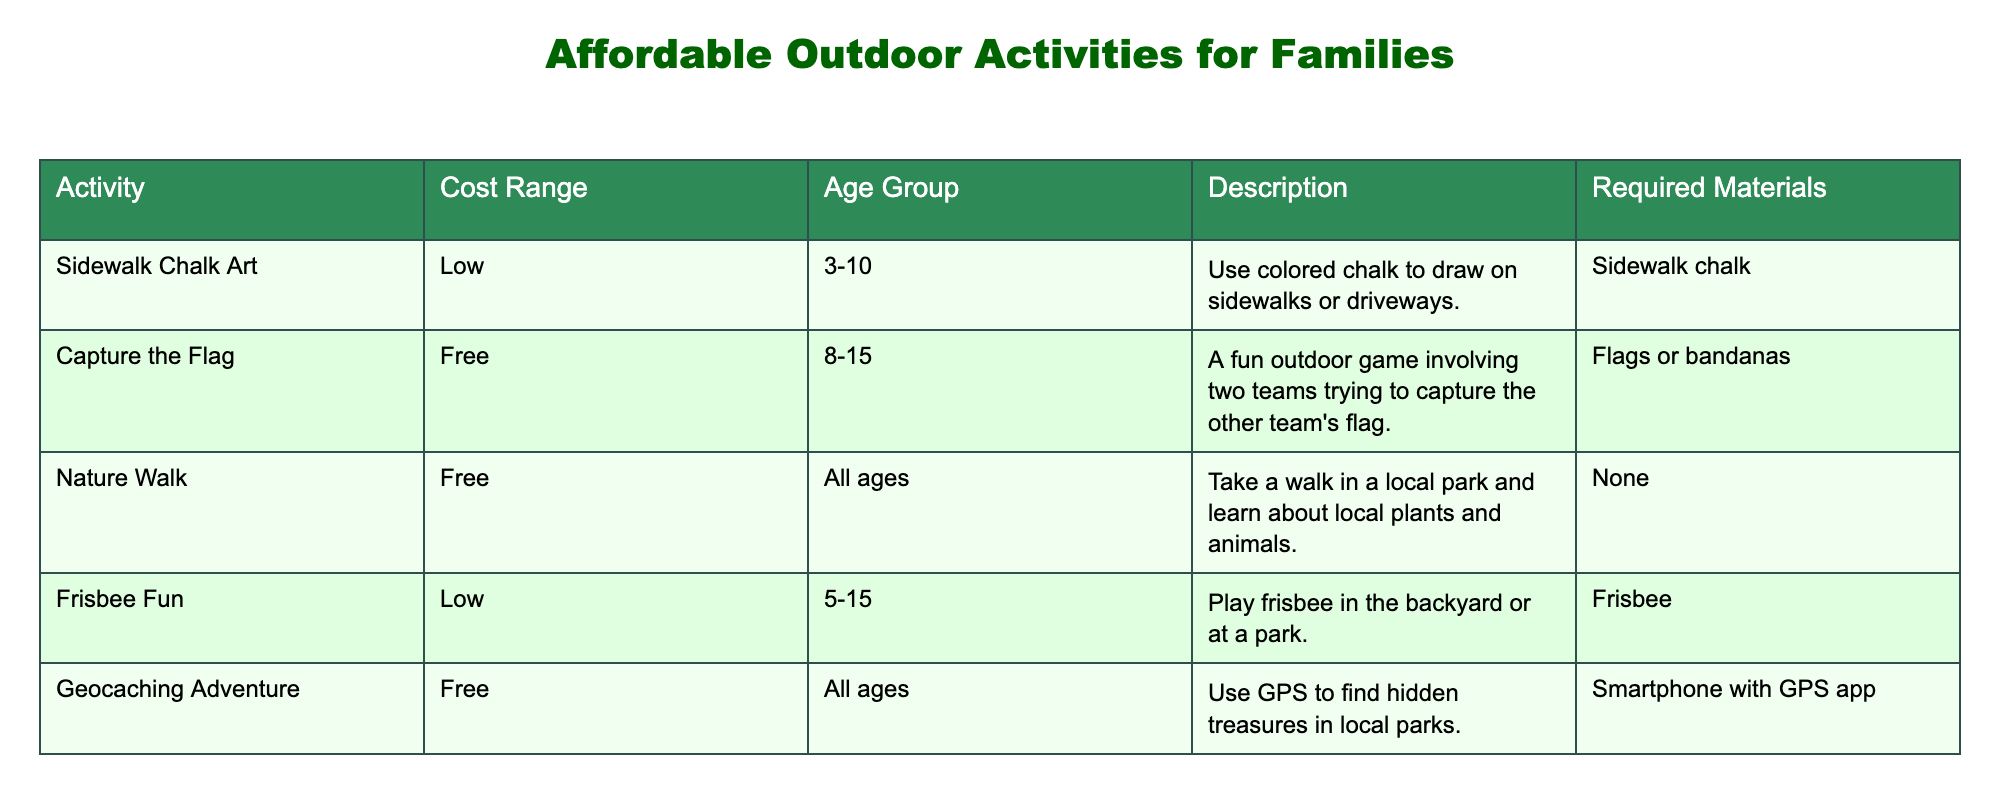What is the cost range for "Sidewalk Chalk Art"? The cost range is specified in the table under the "Cost Range" column for the activity "Sidewalk Chalk Art." It shows "Low."
Answer: Low Which activities are suitable for all ages? The table has a column for age group, and I can look for entries that say "All ages." The activities listed are "Nature Walk" and "Geocaching Adventure."
Answer: Nature Walk, Geocaching Adventure Is "Capture the Flag" the only game listed that is free? To answer this, I check the "Cost Range" column for "Capture the Flag" and see that it lists "Free." Then I look at the other activities and see that "Nature Walk" and "Geocaching Adventure" are also marked as "Free." So, the statement is false.
Answer: No What is the total number of activities with a low-cost range? I count all activities in the table that have "Low" in the "Cost Range" column. The activities are "Sidewalk Chalk Art," "Frisbee Fun." There are 2 low-cost activities.
Answer: 2 Find the most expensive activity listed. The table does not explicitly provide high-cost activities. However, I can look at the descriptions of the activities with varying cost ranges. As all listed are free or low, it appears none are expensive. However, since they are all categorized as "Low" or "Free," I conclude there isn't an expensive activity.
Answer: None How many activities can be played by children aged 10 and below? To find this, I look at the age group of each activity in the table. "Sidewalk Chalk Art" (3-10), "Frisbee Fun" (5-15), and "Nature Walk" (All ages) allow participation from children aged ten and below. So there are three suitable activities for this age group.
Answer: 3 Which activity requires a smartphone? The "Geocaching Adventure" is the only activity that mentions requiring specific materials, stating that a "Smartphone with GPS app" is needed. By cross-referencing required materials with activities, it stands out as the unique requirement.
Answer: Geocaching Adventure How many of the activities listed involve teamwork? To determine this, I look for activities that explicitly require more than one person. "Capture the Flag" explicitly states it involves two teams. "Geocaching Adventure" could involve teamwork, too, as families often participate together, but it's not specified. So, "Capture the Flag" is defined clearly; hence there is 1.
Answer: 1 